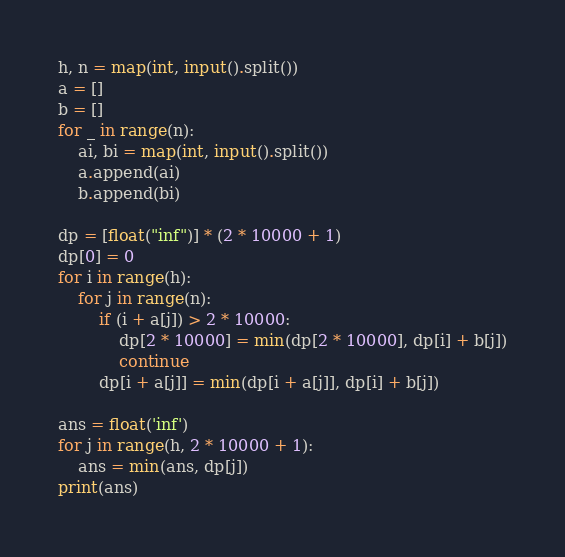<code> <loc_0><loc_0><loc_500><loc_500><_Python_>h, n = map(int, input().split())
a = []
b = []
for _ in range(n):
    ai, bi = map(int, input().split())
    a.append(ai)
    b.append(bi)
 
dp = [float("inf")] * (2 * 10000 + 1)
dp[0] = 0
for i in range(h):
    for j in range(n):
        if (i + a[j]) > 2 * 10000:
            dp[2 * 10000] = min(dp[2 * 10000], dp[i] + b[j])
            continue
        dp[i + a[j]] = min(dp[i + a[j]], dp[i] + b[j])
 
ans = float('inf')
for j in range(h, 2 * 10000 + 1):
    ans = min(ans, dp[j])
print(ans)</code> 